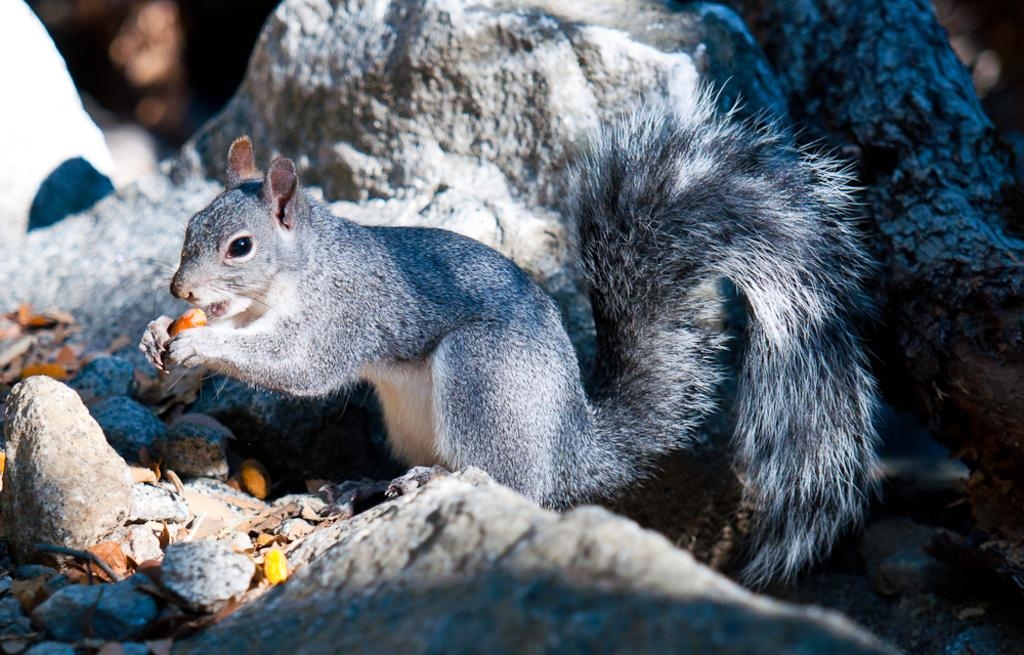What animal can be seen in the image? There is a squirrel in the image. What is the squirrel doing in the image? The squirrel is holding a food item. What type of natural elements are visible in the background of the image? There are rocks in the background of the image. What type of ground elements are visible at the bottom of the image? There are stones at the bottom of the image. What books can be seen in the image? There are no books present in the image. What statement does the squirrel make in the image? The squirrel does not make any statements in the image, as it is an animal and cannot speak. 